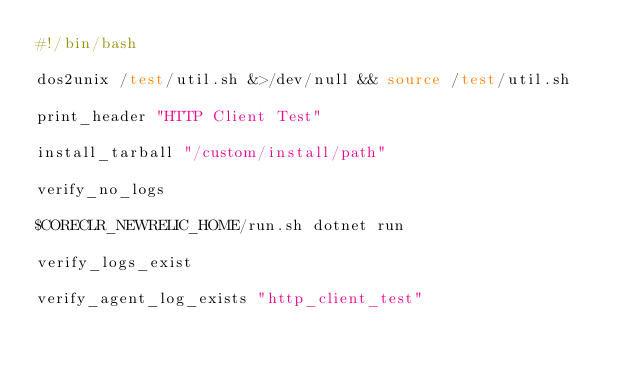<code> <loc_0><loc_0><loc_500><loc_500><_Bash_>#!/bin/bash

dos2unix /test/util.sh &>/dev/null && source /test/util.sh

print_header "HTTP Client Test"

install_tarball "/custom/install/path"

verify_no_logs

$CORECLR_NEWRELIC_HOME/run.sh dotnet run

verify_logs_exist

verify_agent_log_exists "http_client_test"</code> 